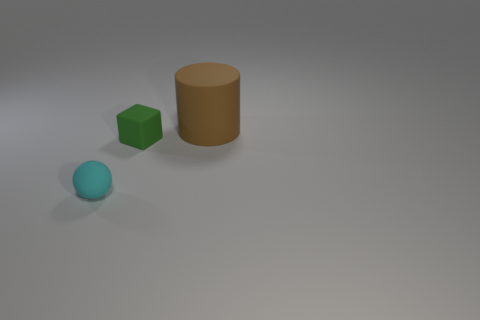Add 2 small balls. How many objects exist? 5 Subtract all balls. How many objects are left? 2 Add 3 small brown matte balls. How many small brown matte balls exist? 3 Subtract 0 cyan cylinders. How many objects are left? 3 Subtract all large green rubber cylinders. Subtract all tiny cyan rubber spheres. How many objects are left? 2 Add 2 tiny cubes. How many tiny cubes are left? 3 